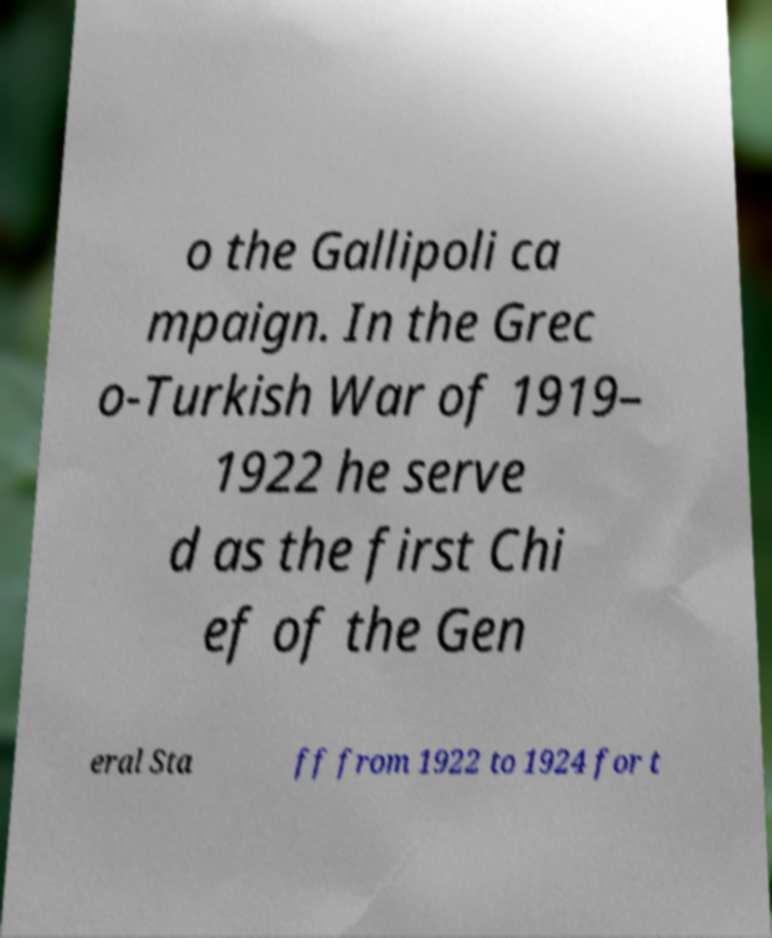Please identify and transcribe the text found in this image. o the Gallipoli ca mpaign. In the Grec o-Turkish War of 1919– 1922 he serve d as the first Chi ef of the Gen eral Sta ff from 1922 to 1924 for t 